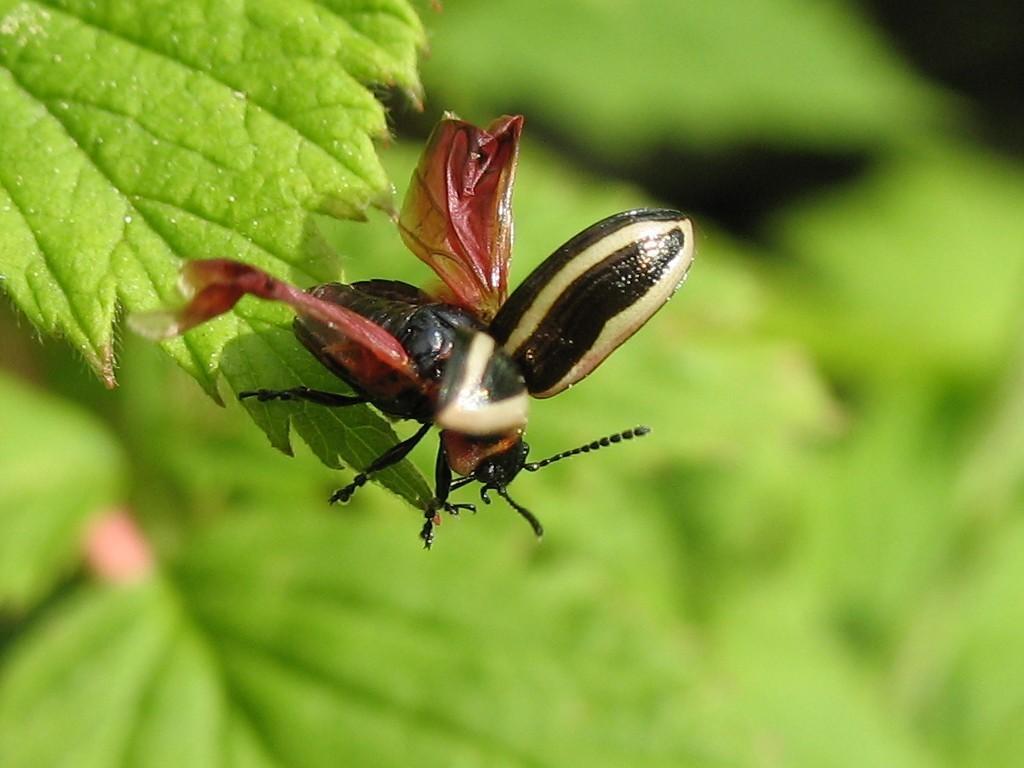How would you summarize this image in a sentence or two? In the top left corner of the image there is a leaf. On the leaf there is an insect. And there is a green background. 